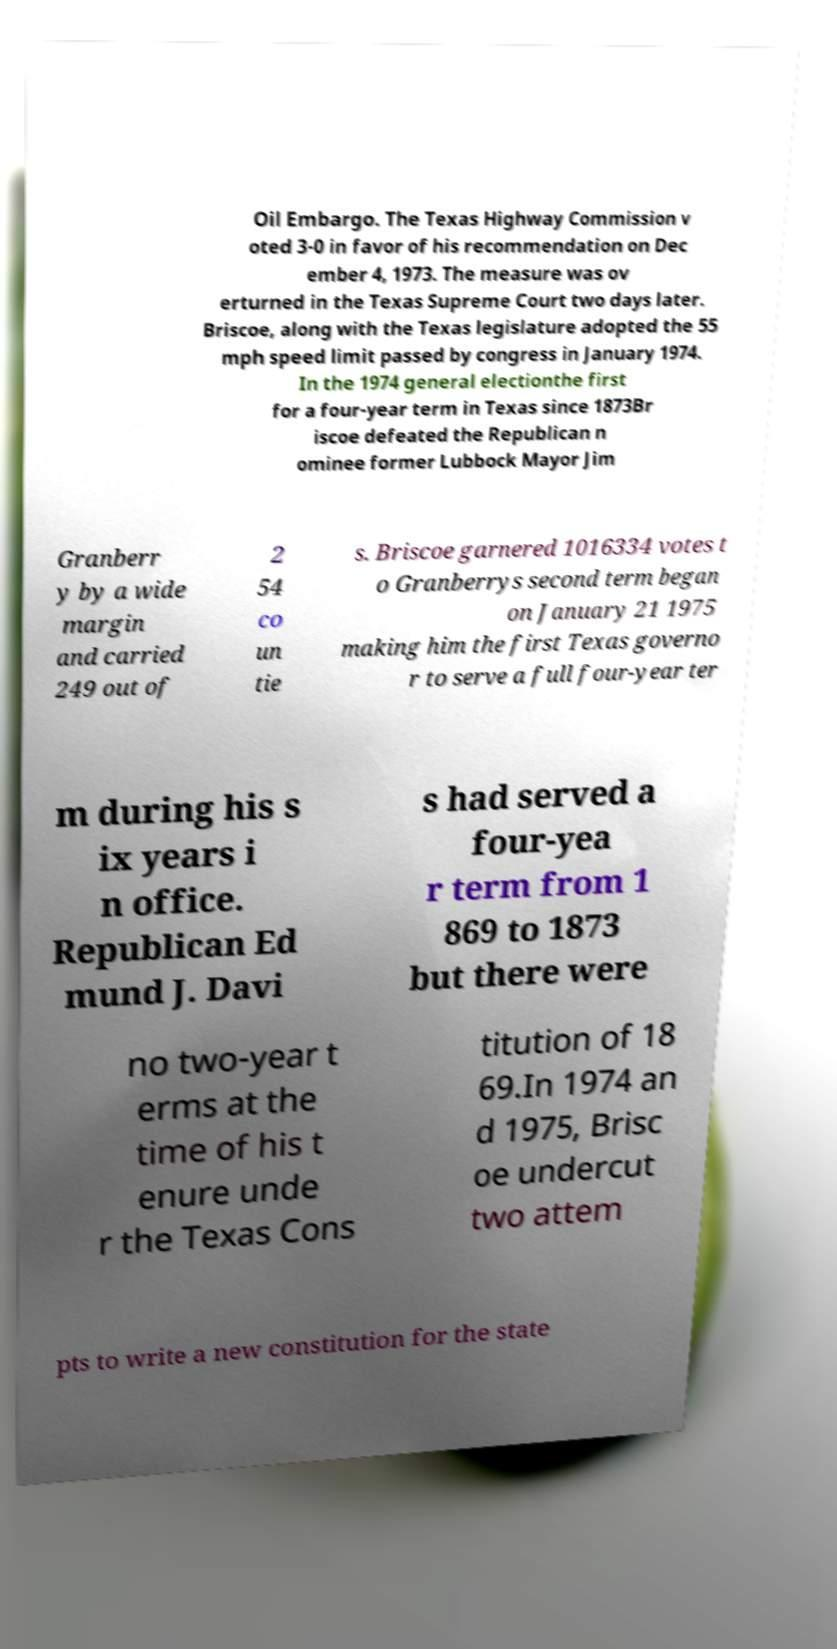Can you read and provide the text displayed in the image?This photo seems to have some interesting text. Can you extract and type it out for me? Oil Embargo. The Texas Highway Commission v oted 3-0 in favor of his recommendation on Dec ember 4, 1973. The measure was ov erturned in the Texas Supreme Court two days later. Briscoe, along with the Texas legislature adopted the 55 mph speed limit passed by congress in January 1974. In the 1974 general electionthe first for a four-year term in Texas since 1873Br iscoe defeated the Republican n ominee former Lubbock Mayor Jim Granberr y by a wide margin and carried 249 out of 2 54 co un tie s. Briscoe garnered 1016334 votes t o Granberrys second term began on January 21 1975 making him the first Texas governo r to serve a full four-year ter m during his s ix years i n office. Republican Ed mund J. Davi s had served a four-yea r term from 1 869 to 1873 but there were no two-year t erms at the time of his t enure unde r the Texas Cons titution of 18 69.In 1974 an d 1975, Brisc oe undercut two attem pts to write a new constitution for the state 